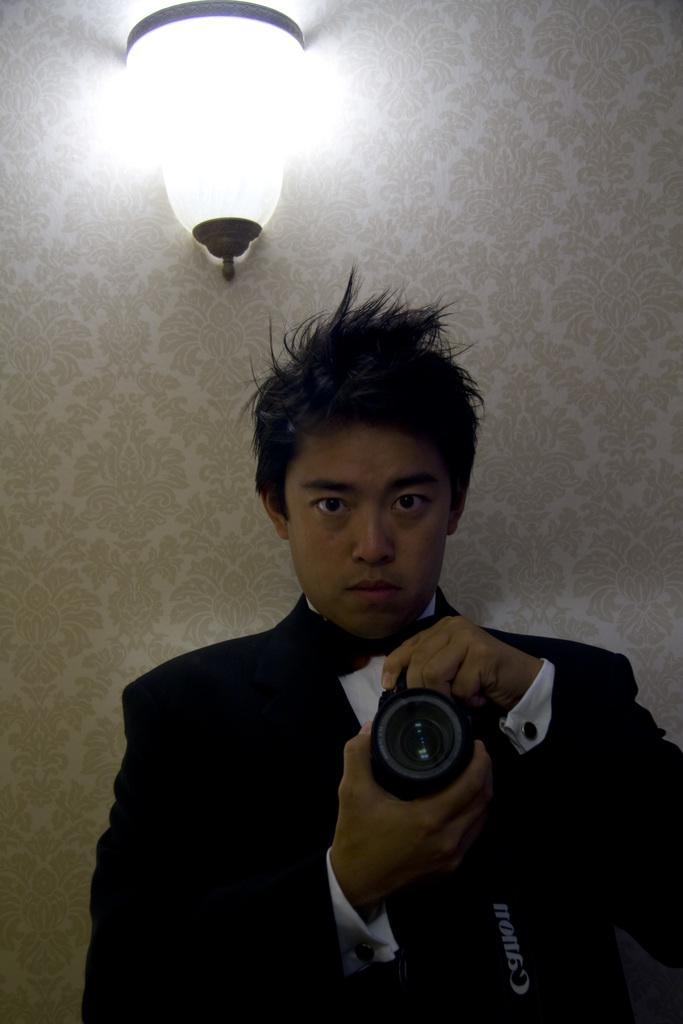Could you give a brief overview of what you see in this image? In this image I can see a man is holding a camera in his hand. On this wall I can see a light. 